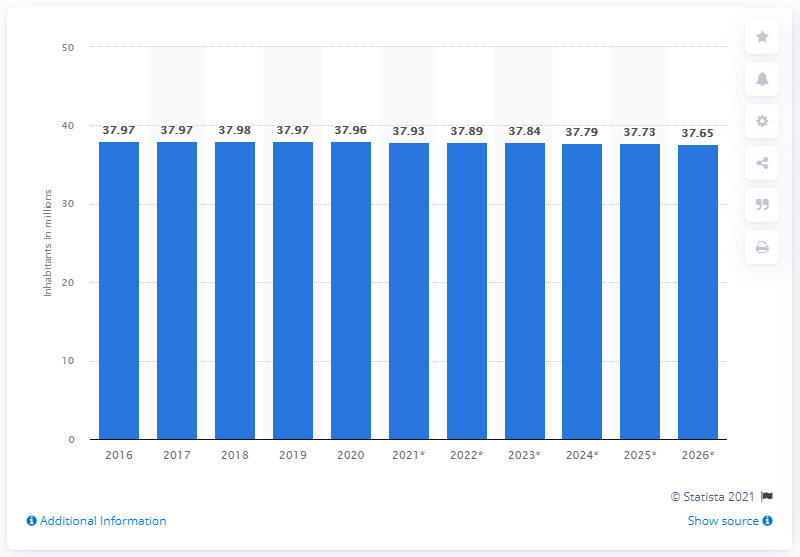What can be inferred about Poland's population trend after 2020? After 2020, the projected population trend for Poland displays a continuation of the decrease seen in previous years. The forecast data from 2021 to 2026 indicate a steady population decline, with each year's estimate slightly lower than the last. Do these numbers include any predictions or are they all actual recorded populations? The chart clearly marks 2021 through 2026 with an asterisk which suggests these numbers are projections rather than actual, recorded populations. It's important to note that such forecasts are informed by current trends but can be influenced by various factors and thus are subject to change. 